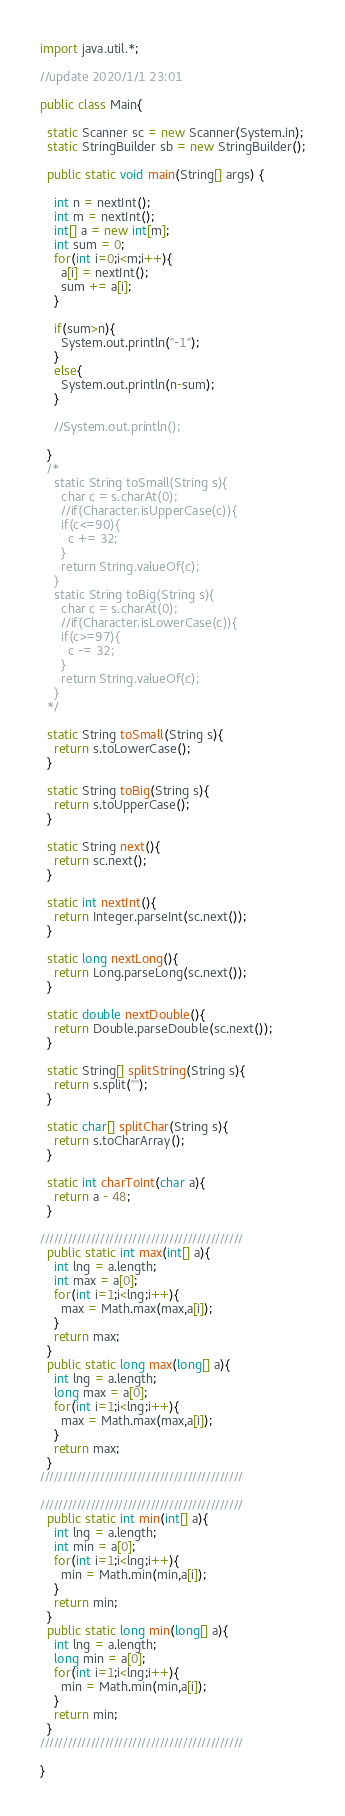Convert code to text. <code><loc_0><loc_0><loc_500><loc_500><_Java_>import java.util.*;

//update 2020/1/1 23:01

public class Main{

  static Scanner sc = new Scanner(System.in);
  static StringBuilder sb = new StringBuilder();

  public static void main(String[] args) {

    int n = nextInt();
    int m = nextInt();
    int[] a = new int[m];
    int sum = 0;
    for(int i=0;i<m;i++){
      a[i] = nextInt();
      sum += a[i];
    }

    if(sum>n){
      System.out.println("-1");
    }
    else{
      System.out.println(n-sum);
    }

    //System.out.println();

  }
  /*
    static String toSmall(String s){
      char c = s.charAt(0);
      //if(Character.isUpperCase(c)){
      if(c<=90){
        c += 32;
      }
      return String.valueOf(c);
    }
    static String toBig(String s){
      char c = s.charAt(0);
      //if(Character.isLowerCase(c)){
      if(c>=97){
        c -= 32;
      }
      return String.valueOf(c);
    }
  */

  static String toSmall(String s){
    return s.toLowerCase();
  }

  static String toBig(String s){
    return s.toUpperCase();
  }

  static String next(){
    return sc.next();
  }

  static int nextInt(){
    return Integer.parseInt(sc.next());
  }

  static long nextLong(){
    return Long.parseLong(sc.next());
  }

  static double nextDouble(){
    return Double.parseDouble(sc.next());
  }

  static String[] splitString(String s){
    return s.split("");
  }

  static char[] splitChar(String s){
    return s.toCharArray();
  }

  static int charToInt(char a){
    return a - 48;
  }

////////////////////////////////////////////
  public static int max(int[] a){
    int lng = a.length;
    int max = a[0];
    for(int i=1;i<lng;i++){
      max = Math.max(max,a[i]);
    }
    return max;
  }
  public static long max(long[] a){
    int lng = a.length;
    long max = a[0];
    for(int i=1;i<lng;i++){
      max = Math.max(max,a[i]);
    }
    return max;
  }
////////////////////////////////////////////

////////////////////////////////////////////
  public static int min(int[] a){
    int lng = a.length;
    int min = a[0];
    for(int i=1;i<lng;i++){
      min = Math.min(min,a[i]);
    }
    return min;
  }
  public static long min(long[] a){
    int lng = a.length;
    long min = a[0];
    for(int i=1;i<lng;i++){
      min = Math.min(min,a[i]);
    }
    return min;
  }
////////////////////////////////////////////

}
</code> 